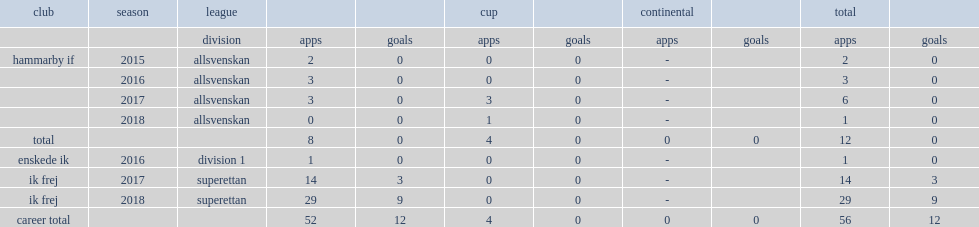Which club did dusan jajic play for in 2015? Hammarby if. 